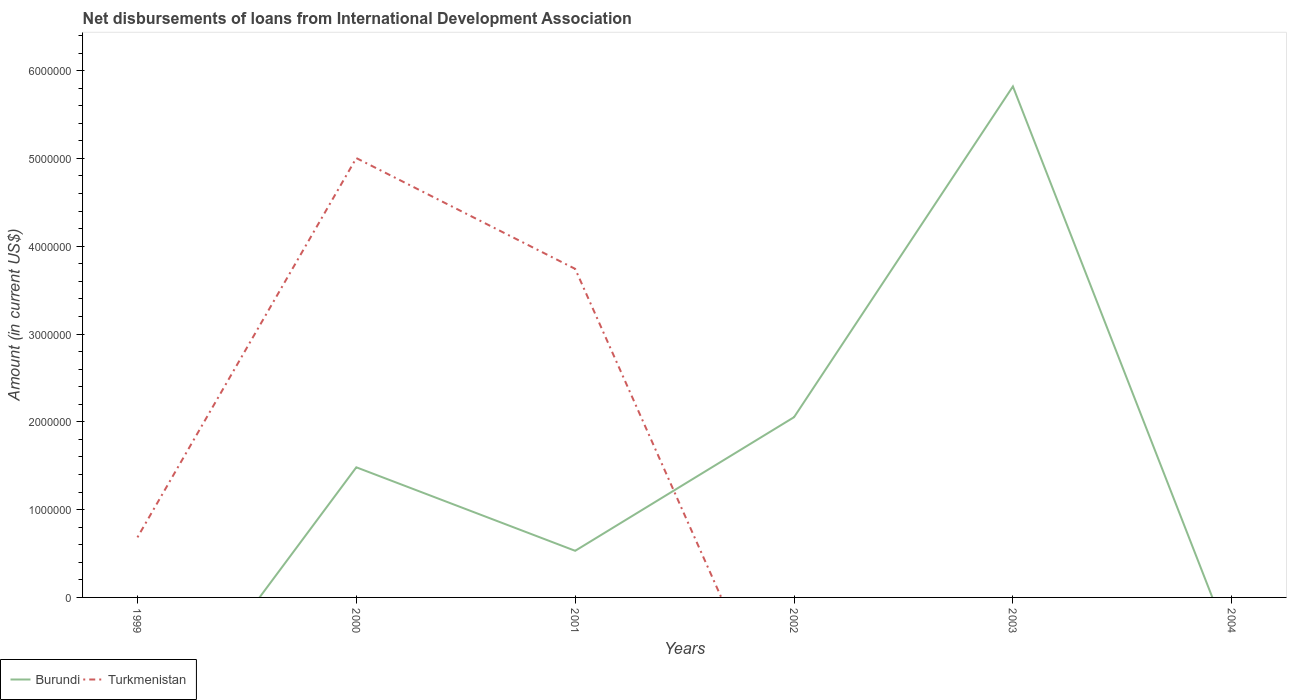How many different coloured lines are there?
Your answer should be compact. 2. Is the number of lines equal to the number of legend labels?
Keep it short and to the point. No. Across all years, what is the maximum amount of loans disbursed in Burundi?
Offer a very short reply. 0. What is the total amount of loans disbursed in Burundi in the graph?
Provide a succinct answer. 9.51e+05. What is the difference between the highest and the second highest amount of loans disbursed in Burundi?
Ensure brevity in your answer.  5.82e+06. Is the amount of loans disbursed in Turkmenistan strictly greater than the amount of loans disbursed in Burundi over the years?
Offer a terse response. No. How many lines are there?
Make the answer very short. 2. How many years are there in the graph?
Your response must be concise. 6. What is the difference between two consecutive major ticks on the Y-axis?
Make the answer very short. 1.00e+06. Does the graph contain grids?
Keep it short and to the point. No. How many legend labels are there?
Offer a terse response. 2. What is the title of the graph?
Your response must be concise. Net disbursements of loans from International Development Association. Does "Myanmar" appear as one of the legend labels in the graph?
Your answer should be compact. No. What is the label or title of the X-axis?
Your response must be concise. Years. What is the label or title of the Y-axis?
Give a very brief answer. Amount (in current US$). What is the Amount (in current US$) of Burundi in 1999?
Keep it short and to the point. 0. What is the Amount (in current US$) in Turkmenistan in 1999?
Offer a very short reply. 6.84e+05. What is the Amount (in current US$) of Burundi in 2000?
Ensure brevity in your answer.  1.48e+06. What is the Amount (in current US$) of Turkmenistan in 2000?
Your answer should be compact. 5.00e+06. What is the Amount (in current US$) of Burundi in 2001?
Provide a succinct answer. 5.31e+05. What is the Amount (in current US$) of Turkmenistan in 2001?
Keep it short and to the point. 3.74e+06. What is the Amount (in current US$) in Burundi in 2002?
Give a very brief answer. 2.05e+06. What is the Amount (in current US$) of Turkmenistan in 2002?
Give a very brief answer. 0. What is the Amount (in current US$) of Burundi in 2003?
Provide a succinct answer. 5.82e+06. What is the Amount (in current US$) in Burundi in 2004?
Ensure brevity in your answer.  0. Across all years, what is the maximum Amount (in current US$) in Burundi?
Offer a very short reply. 5.82e+06. Across all years, what is the maximum Amount (in current US$) in Turkmenistan?
Provide a short and direct response. 5.00e+06. Across all years, what is the minimum Amount (in current US$) of Turkmenistan?
Your response must be concise. 0. What is the total Amount (in current US$) of Burundi in the graph?
Keep it short and to the point. 9.89e+06. What is the total Amount (in current US$) in Turkmenistan in the graph?
Give a very brief answer. 9.43e+06. What is the difference between the Amount (in current US$) of Turkmenistan in 1999 and that in 2000?
Provide a short and direct response. -4.32e+06. What is the difference between the Amount (in current US$) in Turkmenistan in 1999 and that in 2001?
Ensure brevity in your answer.  -3.06e+06. What is the difference between the Amount (in current US$) of Burundi in 2000 and that in 2001?
Your answer should be very brief. 9.51e+05. What is the difference between the Amount (in current US$) in Turkmenistan in 2000 and that in 2001?
Offer a very short reply. 1.26e+06. What is the difference between the Amount (in current US$) of Burundi in 2000 and that in 2002?
Offer a very short reply. -5.71e+05. What is the difference between the Amount (in current US$) in Burundi in 2000 and that in 2003?
Offer a very short reply. -4.34e+06. What is the difference between the Amount (in current US$) in Burundi in 2001 and that in 2002?
Your answer should be very brief. -1.52e+06. What is the difference between the Amount (in current US$) of Burundi in 2001 and that in 2003?
Your response must be concise. -5.29e+06. What is the difference between the Amount (in current US$) of Burundi in 2002 and that in 2003?
Provide a short and direct response. -3.77e+06. What is the difference between the Amount (in current US$) in Burundi in 2000 and the Amount (in current US$) in Turkmenistan in 2001?
Your answer should be very brief. -2.26e+06. What is the average Amount (in current US$) of Burundi per year?
Keep it short and to the point. 1.65e+06. What is the average Amount (in current US$) in Turkmenistan per year?
Ensure brevity in your answer.  1.57e+06. In the year 2000, what is the difference between the Amount (in current US$) of Burundi and Amount (in current US$) of Turkmenistan?
Make the answer very short. -3.52e+06. In the year 2001, what is the difference between the Amount (in current US$) of Burundi and Amount (in current US$) of Turkmenistan?
Provide a short and direct response. -3.21e+06. What is the ratio of the Amount (in current US$) of Turkmenistan in 1999 to that in 2000?
Offer a terse response. 0.14. What is the ratio of the Amount (in current US$) in Turkmenistan in 1999 to that in 2001?
Give a very brief answer. 0.18. What is the ratio of the Amount (in current US$) of Burundi in 2000 to that in 2001?
Provide a succinct answer. 2.79. What is the ratio of the Amount (in current US$) in Turkmenistan in 2000 to that in 2001?
Offer a very short reply. 1.34. What is the ratio of the Amount (in current US$) of Burundi in 2000 to that in 2002?
Give a very brief answer. 0.72. What is the ratio of the Amount (in current US$) in Burundi in 2000 to that in 2003?
Your answer should be very brief. 0.25. What is the ratio of the Amount (in current US$) of Burundi in 2001 to that in 2002?
Your answer should be very brief. 0.26. What is the ratio of the Amount (in current US$) in Burundi in 2001 to that in 2003?
Ensure brevity in your answer.  0.09. What is the ratio of the Amount (in current US$) in Burundi in 2002 to that in 2003?
Your answer should be very brief. 0.35. What is the difference between the highest and the second highest Amount (in current US$) of Burundi?
Provide a succinct answer. 3.77e+06. What is the difference between the highest and the second highest Amount (in current US$) in Turkmenistan?
Offer a terse response. 1.26e+06. What is the difference between the highest and the lowest Amount (in current US$) of Burundi?
Keep it short and to the point. 5.82e+06. What is the difference between the highest and the lowest Amount (in current US$) in Turkmenistan?
Offer a terse response. 5.00e+06. 